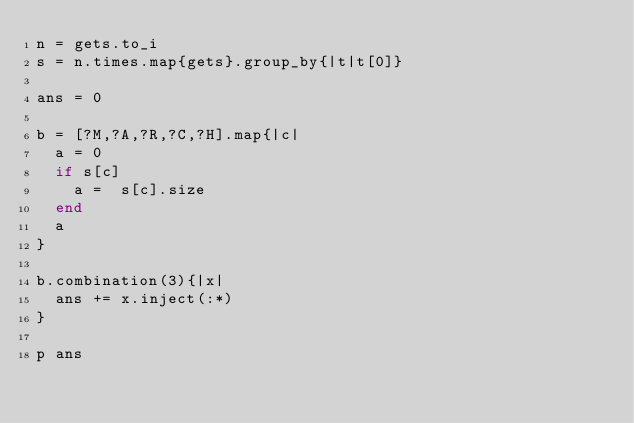Convert code to text. <code><loc_0><loc_0><loc_500><loc_500><_Ruby_>n = gets.to_i
s = n.times.map{gets}.group_by{|t|t[0]}

ans = 0

b = [?M,?A,?R,?C,?H].map{|c|
  a = 0
  if s[c]
    a =  s[c].size
  end
  a
}

b.combination(3){|x|
  ans += x.inject(:*)
}

p ans</code> 